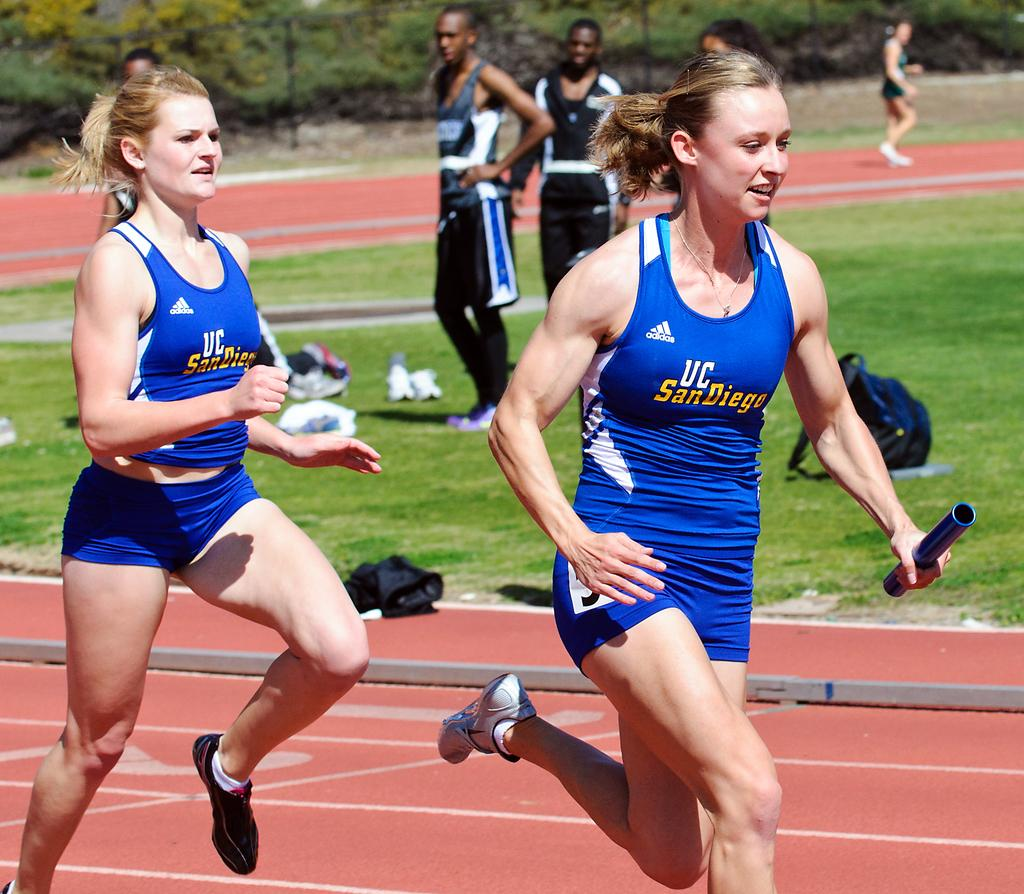<image>
Relay a brief, clear account of the picture shown. A runner for UC San Diego runs down the track with a baton in her hand 